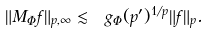<formula> <loc_0><loc_0><loc_500><loc_500>\| M _ { \Phi } f \| _ { p , \infty } \lesssim \ g _ { \Phi } ( p ^ { \prime } ) ^ { 1 / p } \| f \| _ { p } .</formula> 